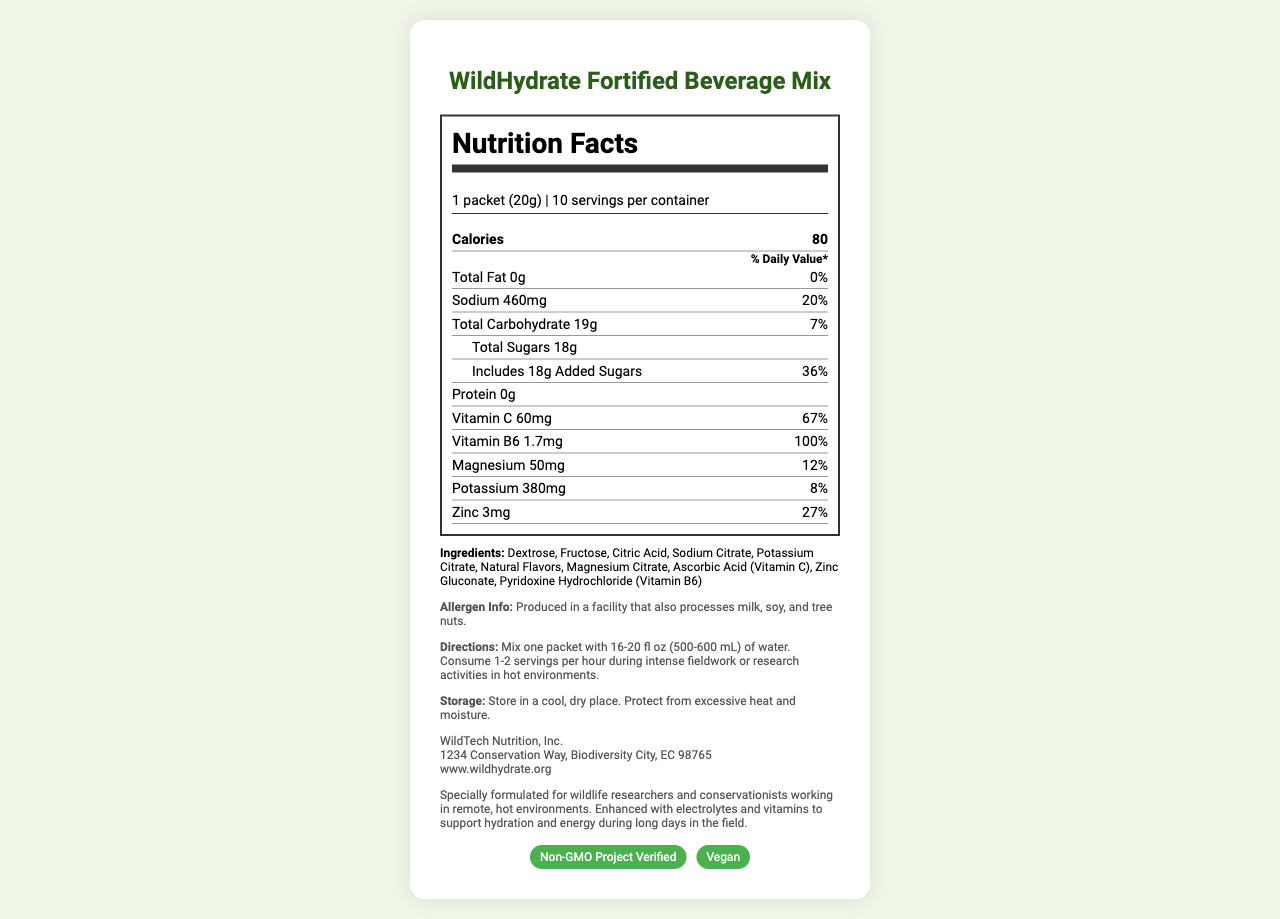what is the serving size? The serving size is specified as "1 packet (20g)" in the document.
Answer: 1 packet (20g) how many servings are in a container? The document states there are 10 servings per container.
Answer: 10 how many calories are in one serving of this beverage mix? The document indicates that one serving contains 80 calories.
Answer: 80 what is the daily value percentage of sodium in one serving? The sodium daily value percentage is given as 20% in the document.
Answer: 20% what is the amount of vitamin C per serving? The amount of vitamin C in one serving is specified as 60mg.
Answer: 60mg what is the total carbohydrate content per serving? A. 7g B. 14g C. 19g D. 25g The total carbohydrate content per serving is 19g as stated in the document.
Answer: C. 19g which of the following vitamins does the beverage mix mainly provide? I. Vitamin B6 II. Vitamin D III. Vitamin C IV. Vitamin E Vitamin B6 and Vitamin C are the main vitamins provided, as indicated by their amounts and daily values.
Answer: I. Vitamin B6 and III. Vitamin C is this product suitable for vegans? The document includes a certification indicating that the product is vegan.
Answer: Yes is the product GMO-free? The document states that the product is "Non-GMO Project Verified."
Answer: Yes does this product contain any protein? The document specifies the protein content as "0g."
Answer: No describe the main idea of this document. The summary of the document focuses on providing nutritional information, ingredients, usage directions, storage instructions, manufacturer details, and certifications relevant to the WildHydrate Fortified Beverage Mix.
Answer: This document provides the nutrition facts for WildHydrate Fortified Beverage Mix, a product designed to combat dehydration for wildlife researchers working in hot, remote environments. It includes details about serving size, nutrient content, ingredients, allergen information, and certifications. what is the primary use of this beverage mix? The document explicitly states that the beverage mix is specially formulated for wildlife researchers and conservationists working in remote, hot environments to support hydration and energy.
Answer: To combat dehydration during intense fieldwork or research activities in hot environments. what flavors are listed for the beverage mix? The document lists "Natural Flavors" as an ingredient but does not specify the exact flavors.
Answer: Not mentioned/Unknown what should you do if you have a milk allergy? The allergen information section mentions that the product is produced in a facility that also processes milk.
Answer: Exercise caution as the product is produced in a facility that also processes milk. what is the website address of the manufacturer? The document provides the manufacturer's website address as www.wildhydrate.org.
Answer: www.wildhydrate.org who manufactures WildHydrate Fortified Beverage Mix? The manufacturer is listed as WildTech Nutrition, Inc. in the document.
Answer: WildTech Nutrition, Inc. 